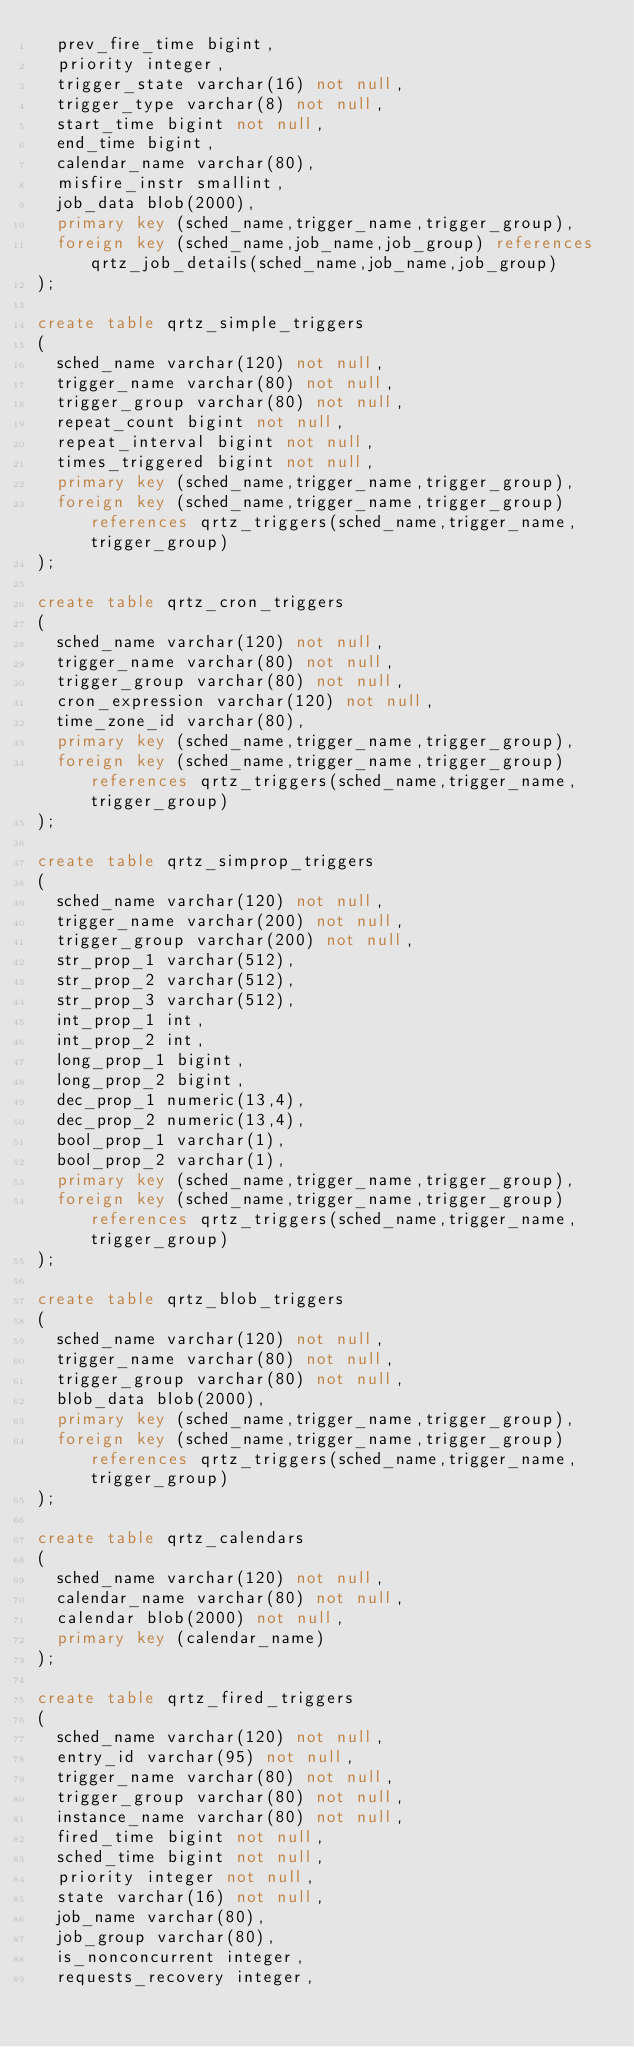<code> <loc_0><loc_0><loc_500><loc_500><_SQL_>	prev_fire_time bigint,
	priority integer,
	trigger_state varchar(16) not null,
	trigger_type varchar(8) not null,
	start_time bigint not null,
	end_time bigint,
	calendar_name varchar(80),
	misfire_instr smallint,
	job_data blob(2000),
	primary key (sched_name,trigger_name,trigger_group),
	foreign key (sched_name,job_name,job_group) references qrtz_job_details(sched_name,job_name,job_group)
);

create table qrtz_simple_triggers
(
	sched_name varchar(120) not null,
	trigger_name varchar(80) not null,
	trigger_group varchar(80) not null,
	repeat_count bigint not null,
	repeat_interval bigint not null,
	times_triggered bigint not null,
	primary key (sched_name,trigger_name,trigger_group),
	foreign key (sched_name,trigger_name,trigger_group) references qrtz_triggers(sched_name,trigger_name,trigger_group)
);

create table qrtz_cron_triggers
(
	sched_name varchar(120) not null,
	trigger_name varchar(80) not null,
	trigger_group varchar(80) not null,
	cron_expression varchar(120) not null,
	time_zone_id varchar(80),
	primary key (sched_name,trigger_name,trigger_group),
	foreign key (sched_name,trigger_name,trigger_group) references qrtz_triggers(sched_name,trigger_name,trigger_group)
);

create table qrtz_simprop_triggers
(          
	sched_name varchar(120) not null,
	trigger_name varchar(200) not null,
	trigger_group varchar(200) not null,
	str_prop_1 varchar(512),
	str_prop_2 varchar(512),
	str_prop_3 varchar(512),
	int_prop_1 int,
	int_prop_2 int,
	long_prop_1 bigint,
	long_prop_2 bigint,
	dec_prop_1 numeric(13,4),
	dec_prop_2 numeric(13,4),
	bool_prop_1 varchar(1),
	bool_prop_2 varchar(1),
	primary key (sched_name,trigger_name,trigger_group),
	foreign key (sched_name,trigger_name,trigger_group) references qrtz_triggers(sched_name,trigger_name,trigger_group)
);

create table qrtz_blob_triggers
(
	sched_name varchar(120) not null,
	trigger_name varchar(80) not null,
	trigger_group varchar(80) not null,
	blob_data blob(2000),
	primary key (sched_name,trigger_name,trigger_group),
	foreign key (sched_name,trigger_name,trigger_group) references qrtz_triggers(sched_name,trigger_name,trigger_group)
);

create table qrtz_calendars
(
	sched_name varchar(120) not null,
	calendar_name varchar(80) not null,
	calendar blob(2000) not null,
	primary key (calendar_name)
);

create table qrtz_fired_triggers
(
	sched_name varchar(120) not null,
	entry_id varchar(95) not null,
	trigger_name varchar(80) not null,
	trigger_group varchar(80) not null,
	instance_name varchar(80) not null,
	fired_time bigint not null,
	sched_time bigint not null,
	priority integer not null,
	state varchar(16) not null,
	job_name varchar(80),
	job_group varchar(80),
	is_nonconcurrent integer,
	requests_recovery integer,</code> 